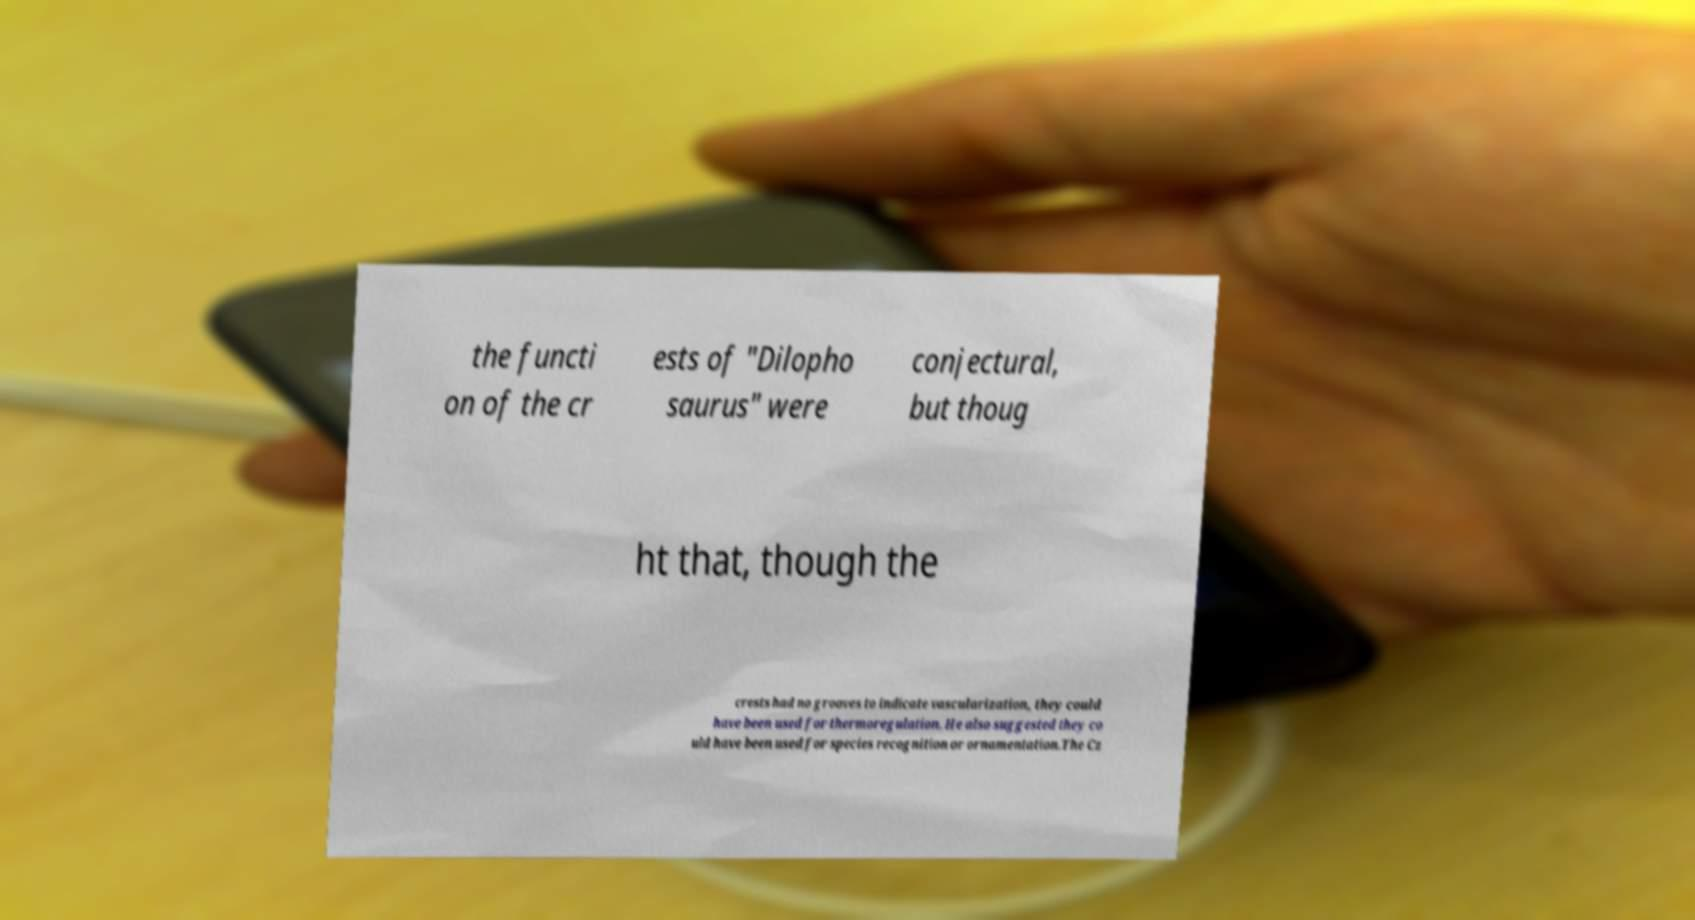Can you accurately transcribe the text from the provided image for me? the functi on of the cr ests of "Dilopho saurus" were conjectural, but thoug ht that, though the crests had no grooves to indicate vascularization, they could have been used for thermoregulation. He also suggested they co uld have been used for species recognition or ornamentation.The Cz 